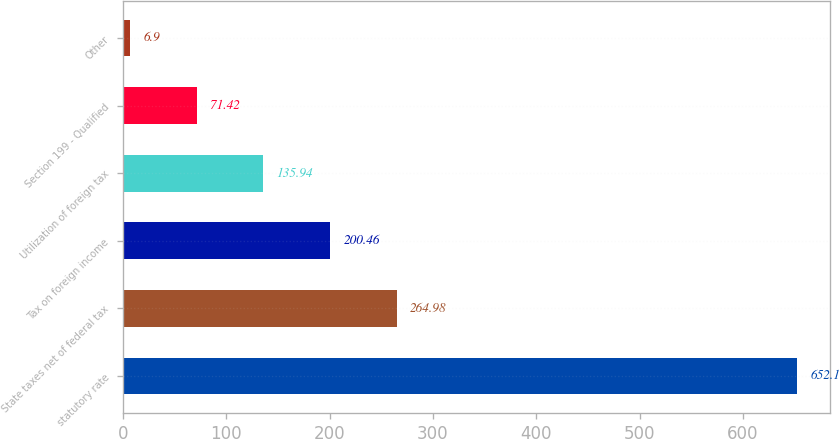Convert chart to OTSL. <chart><loc_0><loc_0><loc_500><loc_500><bar_chart><fcel>statutory rate<fcel>State taxes net of federal tax<fcel>Tax on foreign income<fcel>Utilization of foreign tax<fcel>Section 199 - Qualified<fcel>Other<nl><fcel>652.1<fcel>264.98<fcel>200.46<fcel>135.94<fcel>71.42<fcel>6.9<nl></chart> 